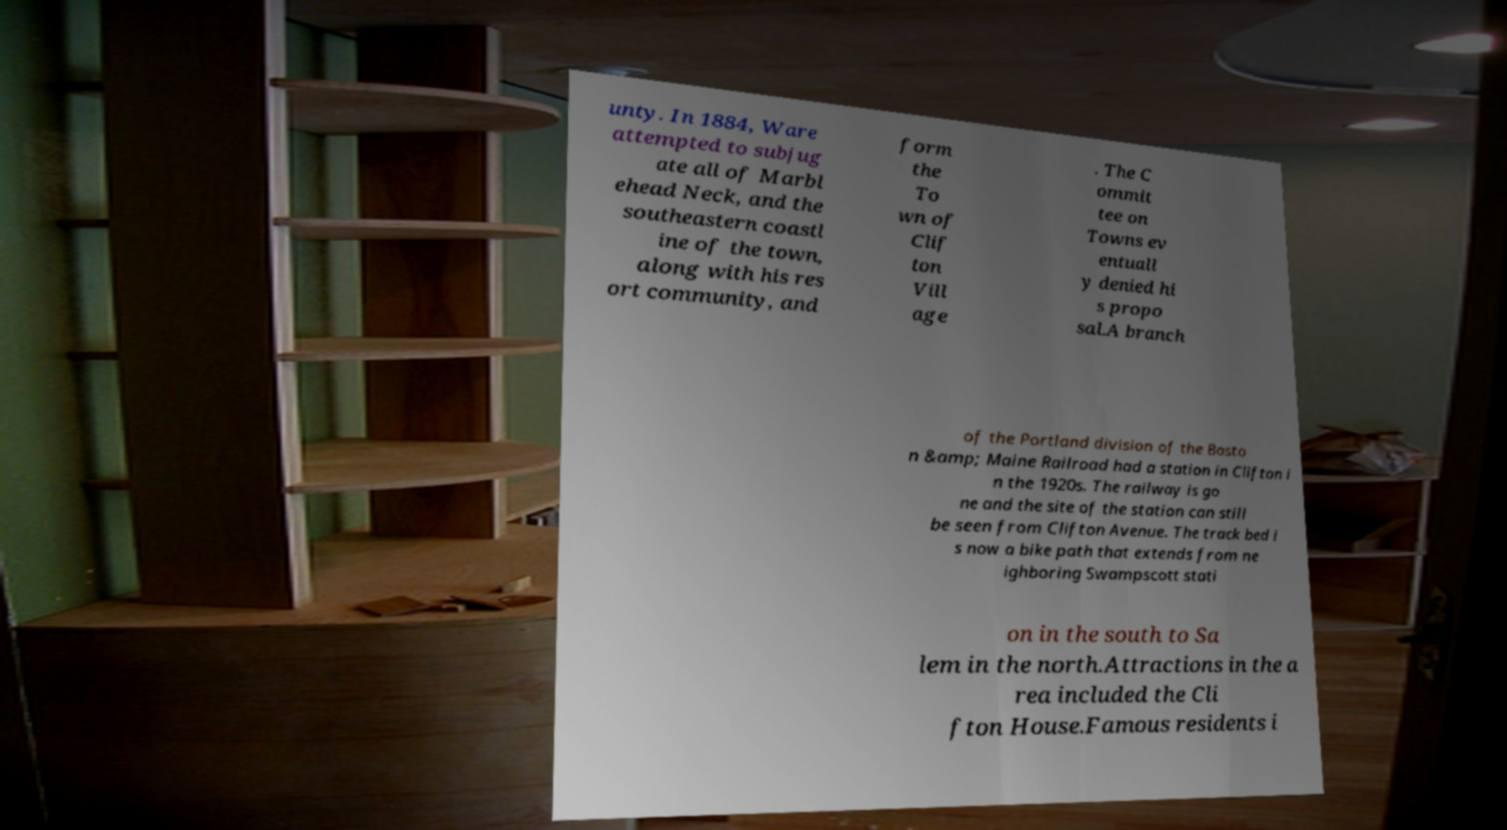There's text embedded in this image that I need extracted. Can you transcribe it verbatim? unty. In 1884, Ware attempted to subjug ate all of Marbl ehead Neck, and the southeastern coastl ine of the town, along with his res ort community, and form the To wn of Clif ton Vill age . The C ommit tee on Towns ev entuall y denied hi s propo sal.A branch of the Portland division of the Bosto n &amp; Maine Railroad had a station in Clifton i n the 1920s. The railway is go ne and the site of the station can still be seen from Clifton Avenue. The track bed i s now a bike path that extends from ne ighboring Swampscott stati on in the south to Sa lem in the north.Attractions in the a rea included the Cli fton House.Famous residents i 